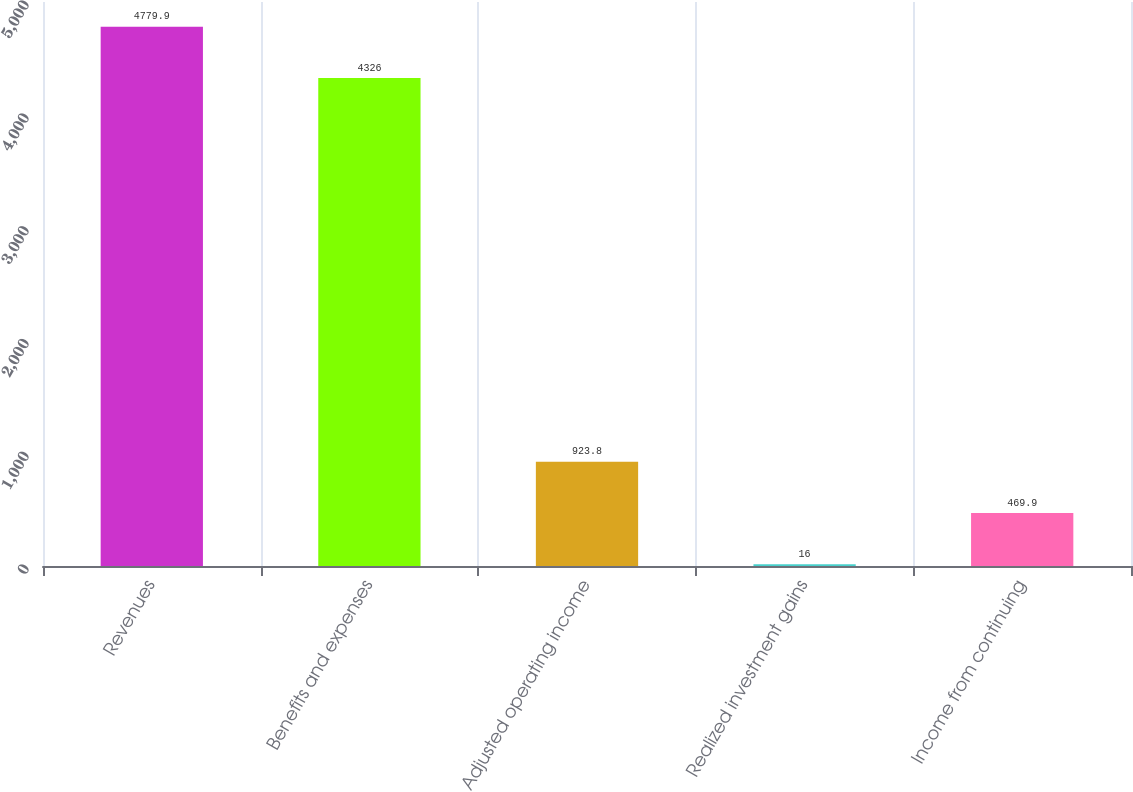Convert chart to OTSL. <chart><loc_0><loc_0><loc_500><loc_500><bar_chart><fcel>Revenues<fcel>Benefits and expenses<fcel>Adjusted operating income<fcel>Realized investment gains<fcel>Income from continuing<nl><fcel>4779.9<fcel>4326<fcel>923.8<fcel>16<fcel>469.9<nl></chart> 